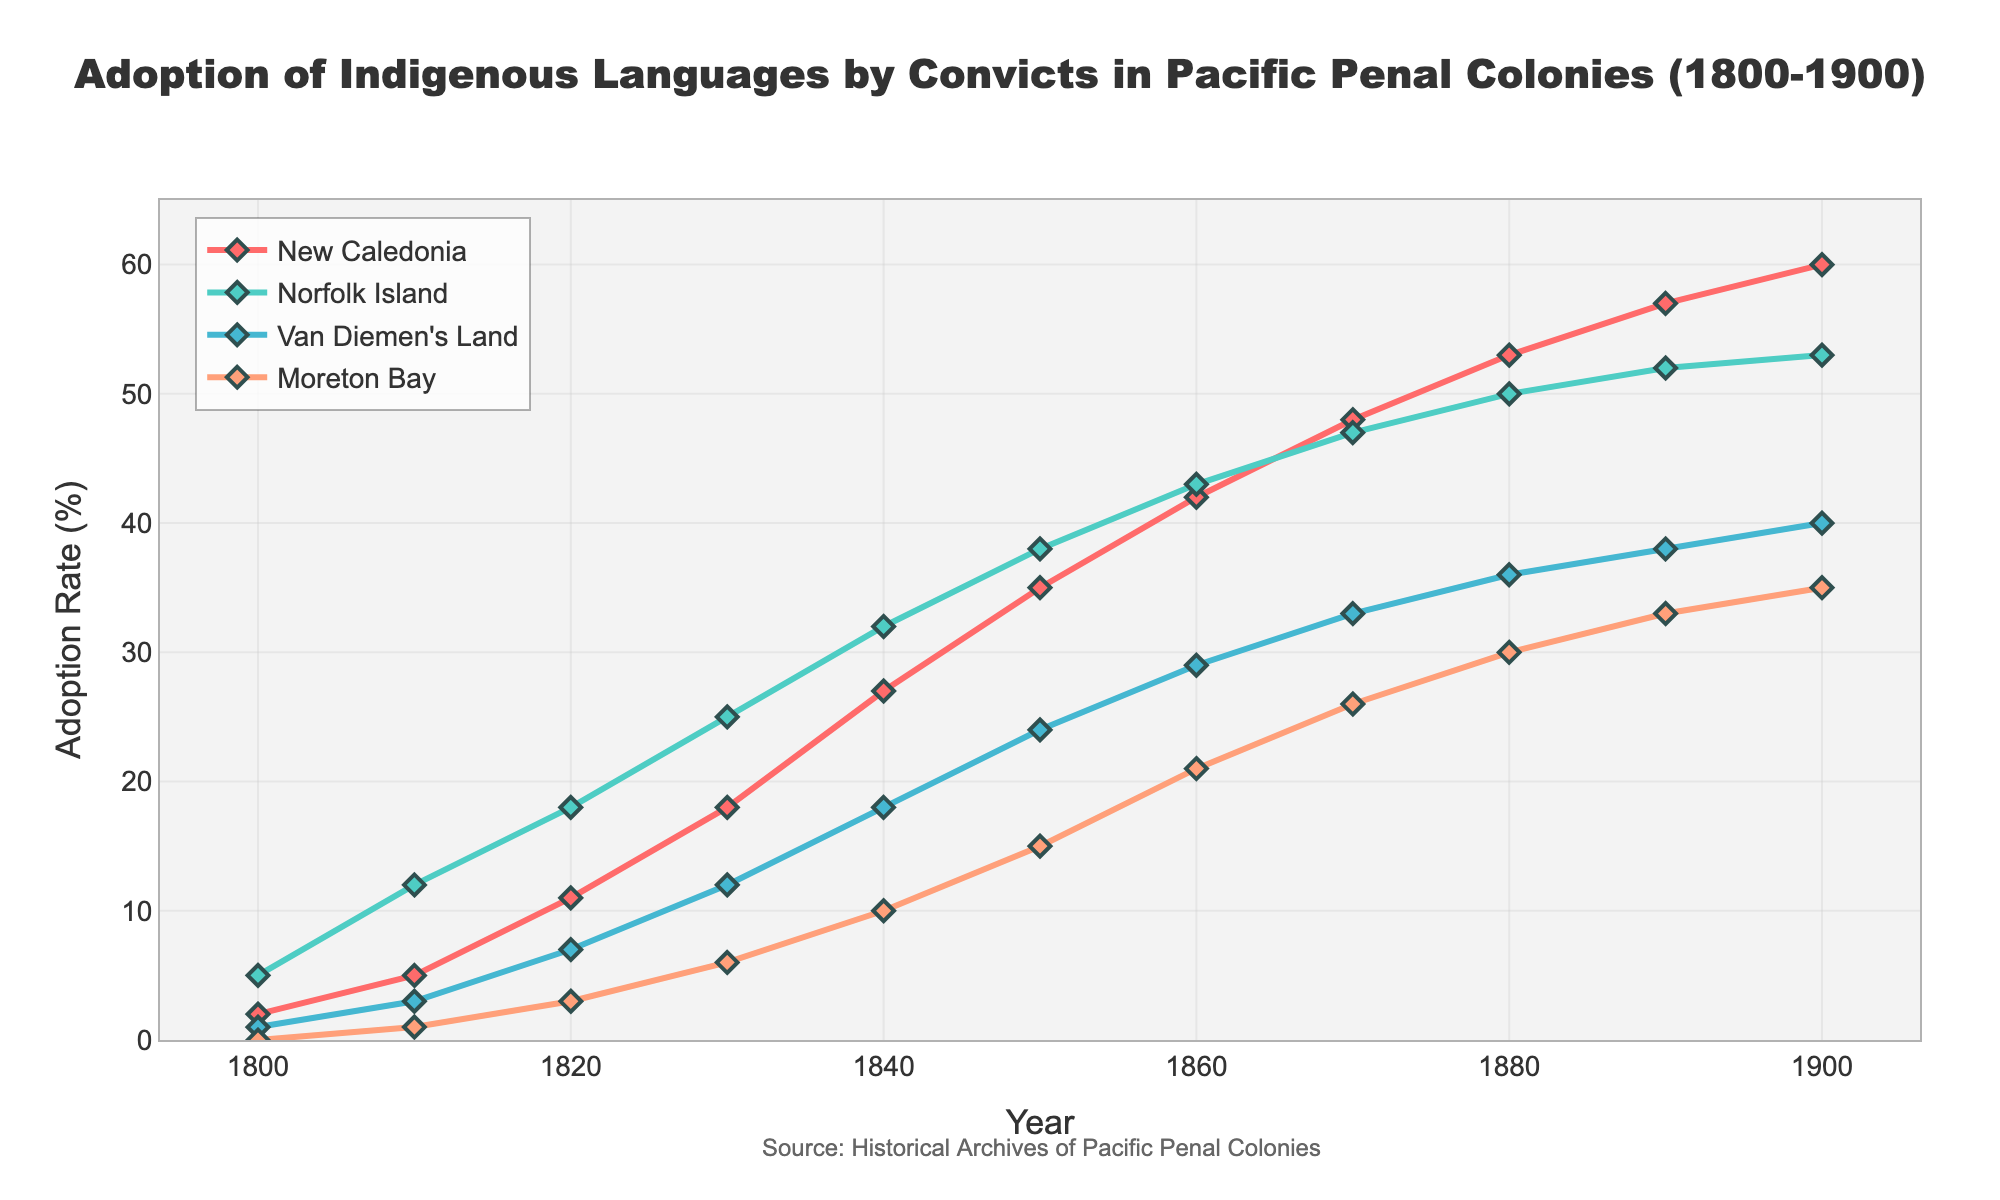What is the adoption rate of indigenous languages in New Caledonia in the year 1850? Look at the data point corresponding to the year 1850 for the line representing New Caledonia. The adoption rate is marked at 35%.
Answer: 35% Which penal colony had the highest adoption rate of indigenous languages in 1800? Compare the data points for all the colonies in the year 1800. The highest adoption rate is for Norfolk Island, which is 5%.
Answer: Norfolk Island What is the overall increase in adoption rate for Van Diemen's Land from 1800 to 1900? Subtract the adoption rate in 1800 from the adoption rate in 1900 for Van Diemen's Land. The rates are 1% in 1800 and 40% in 1900. 40 - 1 gives the overall increase of 39%.
Answer: 39% Which colony had the smallest increase in adoption rates between 1860 and 1870? Calculate the difference between the adoption rates for 1860 and 1870 for all colonies and compare. New Caledonia increased by 6%, Norfolk Island by 4%, Van Diemen's Land by 4%, and Moreton Bay by 5%. The smallest increase is 4%, which corresponds to both Norfolk Island and Van Diemen's Land.
Answer: Norfolk Island, Van Diemen's Land What is the average adoption rate of indigenous languages on Norfolk Island across the whole century (1800-1900)? Sum the adoption rates for Norfolk Island for all the given years and then divide by the number of data points. The sum is 5 + 12 + 18 + 25 + 32 + 38 + 43 + 47 + 50 + 52 + 53 = 375. 375 divided by 11 gives an average of approximately 34.09.
Answer: 34.09 Which two colonies had the same adoption rate in any given year, and what was that rate and year? Check for matching adoption rates in the same year for all colonies. In 1900, both Van Diemen's Land and Moreton Bay had an adoption rate of 35%.
Answer: Van Diemen's Land, Moreton Bay; 35%; 1900 What was the adoption rate difference between Moreton Bay and Norfolk Island in 1880? Subtract the adoption rate of Moreton Bay from Norfolk Island for the year 1880. Rates are 30% for Moreton Bay and 50% for Norfolk Island. 50 - 30 gives a difference of 20%.
Answer: 20% How many years did it take for New Caledonia to reach a 50% adoption rate from its starting point in 1800? Determine the first year New Caledonia's adoption rate reached or passed 50%, which is in 1880. Subtract the starting year 1800 from 1880. The number of years is 1880 - 1800, which equals 80 years.
Answer: 80 years In which decade did Moreton Bay see the highest increase in adoption rate? Calculate the decadal increases for Moreton Bay and compare. The increments are 1% (1800-1810), 2% (1810-1820), 3% (1820-1830), 4% (1830-1840), 5% (1840-1850), 6% (1850-1860), 5% (1860-1870), 4% (1870-1880), 3% (1880-1890), 2% (1890-1900). The highest increase of 6% occurred in the decade from 1850 to 1860.
Answer: 1850 to 1860 